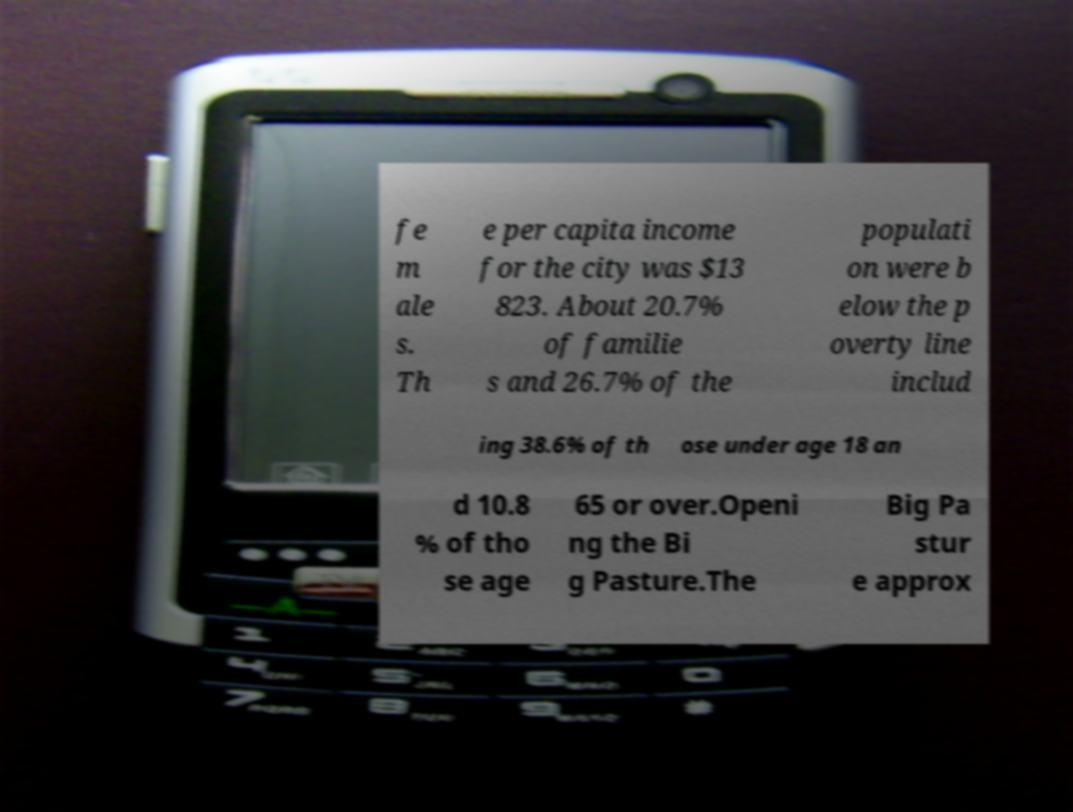Can you accurately transcribe the text from the provided image for me? fe m ale s. Th e per capita income for the city was $13 823. About 20.7% of familie s and 26.7% of the populati on were b elow the p overty line includ ing 38.6% of th ose under age 18 an d 10.8 % of tho se age 65 or over.Openi ng the Bi g Pasture.The Big Pa stur e approx 